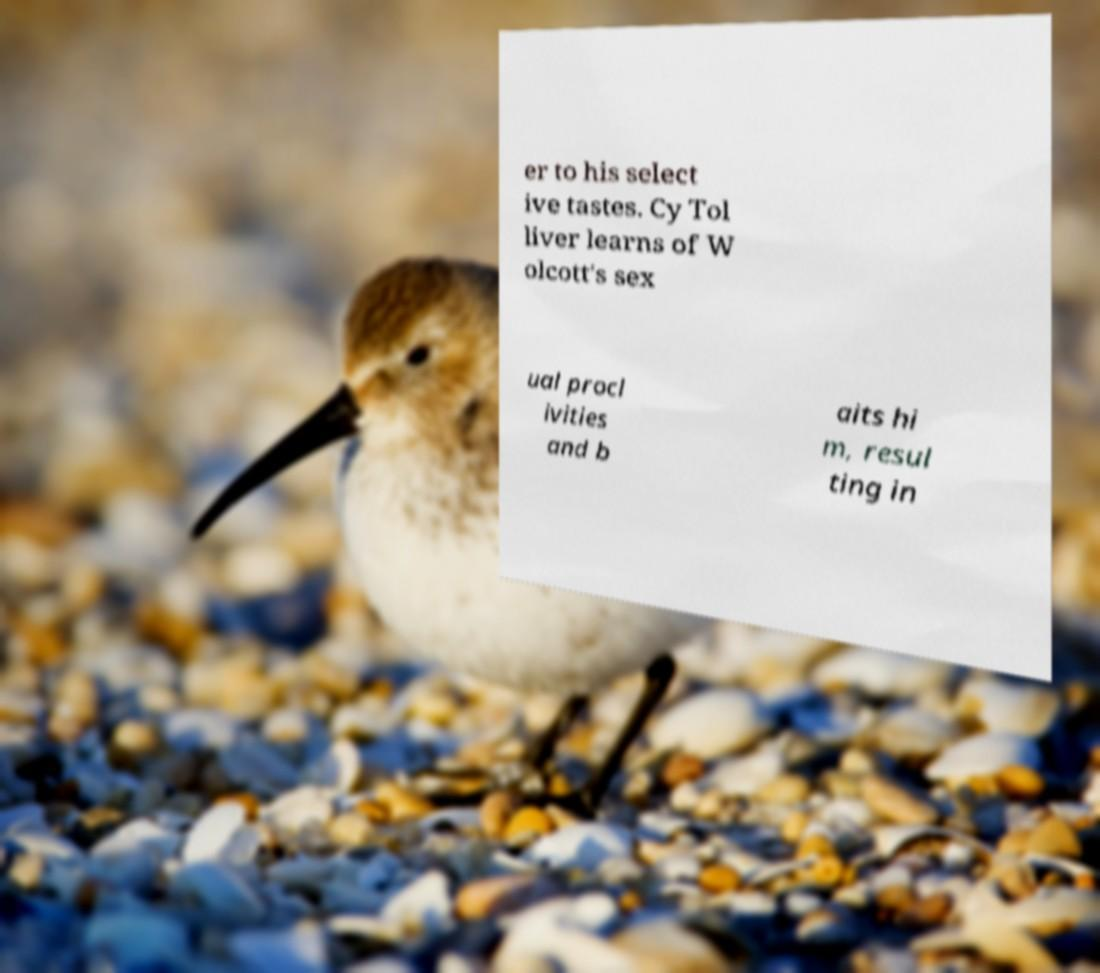Can you accurately transcribe the text from the provided image for me? er to his select ive tastes. Cy Tol liver learns of W olcott's sex ual procl ivities and b aits hi m, resul ting in 